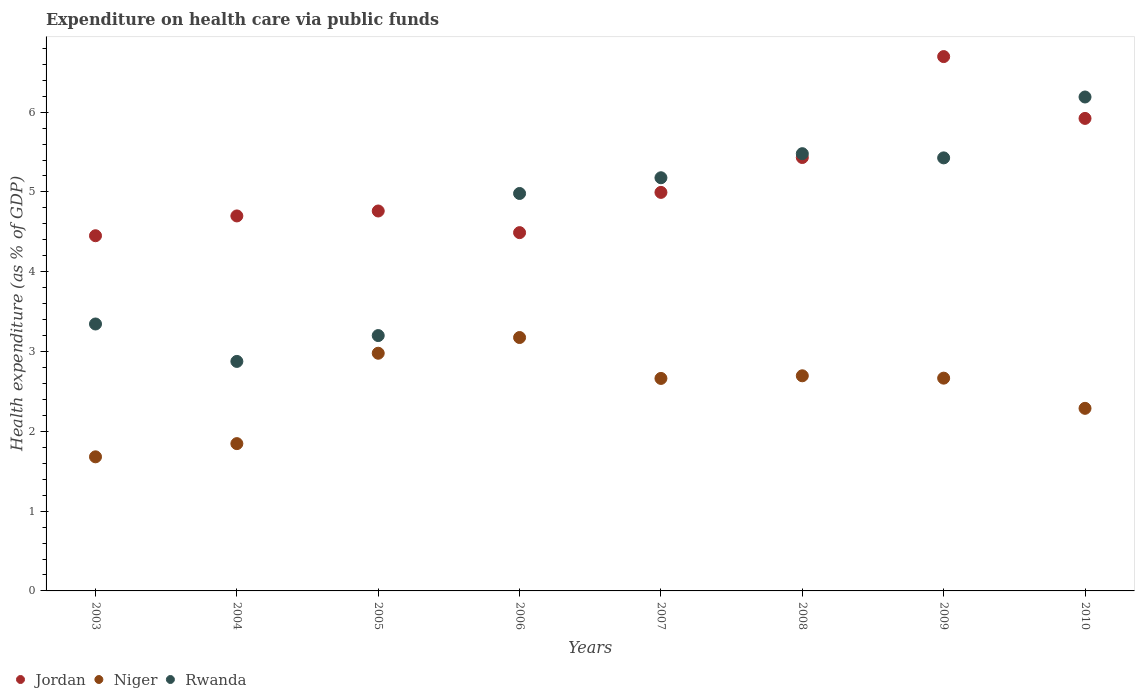Is the number of dotlines equal to the number of legend labels?
Your answer should be very brief. Yes. What is the expenditure made on health care in Niger in 2010?
Ensure brevity in your answer.  2.29. Across all years, what is the maximum expenditure made on health care in Rwanda?
Keep it short and to the point. 6.19. Across all years, what is the minimum expenditure made on health care in Niger?
Keep it short and to the point. 1.68. In which year was the expenditure made on health care in Niger maximum?
Your answer should be very brief. 2006. What is the total expenditure made on health care in Niger in the graph?
Give a very brief answer. 19.99. What is the difference between the expenditure made on health care in Niger in 2008 and that in 2010?
Offer a very short reply. 0.41. What is the difference between the expenditure made on health care in Niger in 2004 and the expenditure made on health care in Jordan in 2007?
Keep it short and to the point. -3.15. What is the average expenditure made on health care in Niger per year?
Give a very brief answer. 2.5. In the year 2006, what is the difference between the expenditure made on health care in Niger and expenditure made on health care in Jordan?
Provide a succinct answer. -1.31. What is the ratio of the expenditure made on health care in Jordan in 2005 to that in 2008?
Your answer should be very brief. 0.88. What is the difference between the highest and the second highest expenditure made on health care in Jordan?
Provide a short and direct response. 0.77. What is the difference between the highest and the lowest expenditure made on health care in Jordan?
Your answer should be compact. 2.24. In how many years, is the expenditure made on health care in Jordan greater than the average expenditure made on health care in Jordan taken over all years?
Your answer should be compact. 3. Is the sum of the expenditure made on health care in Jordan in 2005 and 2008 greater than the maximum expenditure made on health care in Rwanda across all years?
Offer a terse response. Yes. Does the expenditure made on health care in Rwanda monotonically increase over the years?
Your answer should be compact. No. How many dotlines are there?
Your response must be concise. 3. What is the difference between two consecutive major ticks on the Y-axis?
Offer a terse response. 1. Does the graph contain any zero values?
Make the answer very short. No. What is the title of the graph?
Your answer should be compact. Expenditure on health care via public funds. What is the label or title of the Y-axis?
Your answer should be very brief. Health expenditure (as % of GDP). What is the Health expenditure (as % of GDP) of Jordan in 2003?
Your response must be concise. 4.45. What is the Health expenditure (as % of GDP) of Niger in 2003?
Ensure brevity in your answer.  1.68. What is the Health expenditure (as % of GDP) of Rwanda in 2003?
Provide a short and direct response. 3.35. What is the Health expenditure (as % of GDP) in Jordan in 2004?
Your response must be concise. 4.7. What is the Health expenditure (as % of GDP) of Niger in 2004?
Make the answer very short. 1.85. What is the Health expenditure (as % of GDP) in Rwanda in 2004?
Your answer should be very brief. 2.88. What is the Health expenditure (as % of GDP) in Jordan in 2005?
Your answer should be very brief. 4.76. What is the Health expenditure (as % of GDP) of Niger in 2005?
Provide a short and direct response. 2.98. What is the Health expenditure (as % of GDP) of Rwanda in 2005?
Give a very brief answer. 3.2. What is the Health expenditure (as % of GDP) in Jordan in 2006?
Your response must be concise. 4.49. What is the Health expenditure (as % of GDP) in Niger in 2006?
Ensure brevity in your answer.  3.18. What is the Health expenditure (as % of GDP) in Rwanda in 2006?
Your answer should be compact. 4.98. What is the Health expenditure (as % of GDP) in Jordan in 2007?
Give a very brief answer. 4.99. What is the Health expenditure (as % of GDP) of Niger in 2007?
Your response must be concise. 2.66. What is the Health expenditure (as % of GDP) of Rwanda in 2007?
Give a very brief answer. 5.18. What is the Health expenditure (as % of GDP) in Jordan in 2008?
Your answer should be very brief. 5.43. What is the Health expenditure (as % of GDP) in Niger in 2008?
Provide a short and direct response. 2.7. What is the Health expenditure (as % of GDP) in Rwanda in 2008?
Provide a succinct answer. 5.48. What is the Health expenditure (as % of GDP) in Jordan in 2009?
Provide a short and direct response. 6.7. What is the Health expenditure (as % of GDP) in Niger in 2009?
Provide a succinct answer. 2.67. What is the Health expenditure (as % of GDP) in Rwanda in 2009?
Your answer should be very brief. 5.43. What is the Health expenditure (as % of GDP) of Jordan in 2010?
Provide a succinct answer. 5.92. What is the Health expenditure (as % of GDP) in Niger in 2010?
Your response must be concise. 2.29. What is the Health expenditure (as % of GDP) of Rwanda in 2010?
Your answer should be very brief. 6.19. Across all years, what is the maximum Health expenditure (as % of GDP) in Jordan?
Give a very brief answer. 6.7. Across all years, what is the maximum Health expenditure (as % of GDP) of Niger?
Your answer should be very brief. 3.18. Across all years, what is the maximum Health expenditure (as % of GDP) in Rwanda?
Provide a succinct answer. 6.19. Across all years, what is the minimum Health expenditure (as % of GDP) of Jordan?
Your response must be concise. 4.45. Across all years, what is the minimum Health expenditure (as % of GDP) of Niger?
Give a very brief answer. 1.68. Across all years, what is the minimum Health expenditure (as % of GDP) of Rwanda?
Provide a short and direct response. 2.88. What is the total Health expenditure (as % of GDP) of Jordan in the graph?
Your answer should be compact. 41.44. What is the total Health expenditure (as % of GDP) in Niger in the graph?
Provide a short and direct response. 19.99. What is the total Health expenditure (as % of GDP) in Rwanda in the graph?
Keep it short and to the point. 36.67. What is the difference between the Health expenditure (as % of GDP) in Jordan in 2003 and that in 2004?
Provide a short and direct response. -0.25. What is the difference between the Health expenditure (as % of GDP) of Niger in 2003 and that in 2004?
Provide a succinct answer. -0.17. What is the difference between the Health expenditure (as % of GDP) of Rwanda in 2003 and that in 2004?
Make the answer very short. 0.47. What is the difference between the Health expenditure (as % of GDP) of Jordan in 2003 and that in 2005?
Your response must be concise. -0.31. What is the difference between the Health expenditure (as % of GDP) in Niger in 2003 and that in 2005?
Your answer should be very brief. -1.3. What is the difference between the Health expenditure (as % of GDP) in Rwanda in 2003 and that in 2005?
Offer a very short reply. 0.15. What is the difference between the Health expenditure (as % of GDP) of Jordan in 2003 and that in 2006?
Your answer should be very brief. -0.04. What is the difference between the Health expenditure (as % of GDP) of Niger in 2003 and that in 2006?
Your answer should be compact. -1.5. What is the difference between the Health expenditure (as % of GDP) of Rwanda in 2003 and that in 2006?
Your answer should be very brief. -1.64. What is the difference between the Health expenditure (as % of GDP) of Jordan in 2003 and that in 2007?
Offer a very short reply. -0.54. What is the difference between the Health expenditure (as % of GDP) of Niger in 2003 and that in 2007?
Keep it short and to the point. -0.98. What is the difference between the Health expenditure (as % of GDP) in Rwanda in 2003 and that in 2007?
Your answer should be compact. -1.83. What is the difference between the Health expenditure (as % of GDP) of Jordan in 2003 and that in 2008?
Provide a succinct answer. -0.98. What is the difference between the Health expenditure (as % of GDP) of Niger in 2003 and that in 2008?
Make the answer very short. -1.02. What is the difference between the Health expenditure (as % of GDP) in Rwanda in 2003 and that in 2008?
Your answer should be compact. -2.13. What is the difference between the Health expenditure (as % of GDP) in Jordan in 2003 and that in 2009?
Provide a short and direct response. -2.25. What is the difference between the Health expenditure (as % of GDP) of Niger in 2003 and that in 2009?
Your response must be concise. -0.99. What is the difference between the Health expenditure (as % of GDP) in Rwanda in 2003 and that in 2009?
Provide a succinct answer. -2.08. What is the difference between the Health expenditure (as % of GDP) of Jordan in 2003 and that in 2010?
Your answer should be compact. -1.47. What is the difference between the Health expenditure (as % of GDP) in Niger in 2003 and that in 2010?
Ensure brevity in your answer.  -0.61. What is the difference between the Health expenditure (as % of GDP) of Rwanda in 2003 and that in 2010?
Your answer should be compact. -2.84. What is the difference between the Health expenditure (as % of GDP) in Jordan in 2004 and that in 2005?
Give a very brief answer. -0.06. What is the difference between the Health expenditure (as % of GDP) in Niger in 2004 and that in 2005?
Provide a succinct answer. -1.13. What is the difference between the Health expenditure (as % of GDP) in Rwanda in 2004 and that in 2005?
Your answer should be compact. -0.32. What is the difference between the Health expenditure (as % of GDP) in Jordan in 2004 and that in 2006?
Provide a short and direct response. 0.21. What is the difference between the Health expenditure (as % of GDP) of Niger in 2004 and that in 2006?
Provide a short and direct response. -1.33. What is the difference between the Health expenditure (as % of GDP) of Rwanda in 2004 and that in 2006?
Provide a succinct answer. -2.1. What is the difference between the Health expenditure (as % of GDP) in Jordan in 2004 and that in 2007?
Make the answer very short. -0.29. What is the difference between the Health expenditure (as % of GDP) in Niger in 2004 and that in 2007?
Provide a short and direct response. -0.82. What is the difference between the Health expenditure (as % of GDP) in Rwanda in 2004 and that in 2007?
Your answer should be compact. -2.3. What is the difference between the Health expenditure (as % of GDP) of Jordan in 2004 and that in 2008?
Ensure brevity in your answer.  -0.73. What is the difference between the Health expenditure (as % of GDP) in Niger in 2004 and that in 2008?
Keep it short and to the point. -0.85. What is the difference between the Health expenditure (as % of GDP) of Rwanda in 2004 and that in 2008?
Provide a short and direct response. -2.6. What is the difference between the Health expenditure (as % of GDP) of Jordan in 2004 and that in 2009?
Make the answer very short. -2. What is the difference between the Health expenditure (as % of GDP) of Niger in 2004 and that in 2009?
Your answer should be compact. -0.82. What is the difference between the Health expenditure (as % of GDP) of Rwanda in 2004 and that in 2009?
Keep it short and to the point. -2.55. What is the difference between the Health expenditure (as % of GDP) of Jordan in 2004 and that in 2010?
Keep it short and to the point. -1.22. What is the difference between the Health expenditure (as % of GDP) in Niger in 2004 and that in 2010?
Keep it short and to the point. -0.44. What is the difference between the Health expenditure (as % of GDP) in Rwanda in 2004 and that in 2010?
Provide a succinct answer. -3.31. What is the difference between the Health expenditure (as % of GDP) in Jordan in 2005 and that in 2006?
Provide a short and direct response. 0.27. What is the difference between the Health expenditure (as % of GDP) in Niger in 2005 and that in 2006?
Make the answer very short. -0.2. What is the difference between the Health expenditure (as % of GDP) in Rwanda in 2005 and that in 2006?
Your answer should be very brief. -1.78. What is the difference between the Health expenditure (as % of GDP) of Jordan in 2005 and that in 2007?
Provide a succinct answer. -0.23. What is the difference between the Health expenditure (as % of GDP) in Niger in 2005 and that in 2007?
Provide a succinct answer. 0.32. What is the difference between the Health expenditure (as % of GDP) in Rwanda in 2005 and that in 2007?
Keep it short and to the point. -1.98. What is the difference between the Health expenditure (as % of GDP) in Jordan in 2005 and that in 2008?
Your response must be concise. -0.67. What is the difference between the Health expenditure (as % of GDP) of Niger in 2005 and that in 2008?
Offer a terse response. 0.28. What is the difference between the Health expenditure (as % of GDP) in Rwanda in 2005 and that in 2008?
Offer a very short reply. -2.28. What is the difference between the Health expenditure (as % of GDP) in Jordan in 2005 and that in 2009?
Make the answer very short. -1.93. What is the difference between the Health expenditure (as % of GDP) in Niger in 2005 and that in 2009?
Keep it short and to the point. 0.31. What is the difference between the Health expenditure (as % of GDP) in Rwanda in 2005 and that in 2009?
Your response must be concise. -2.23. What is the difference between the Health expenditure (as % of GDP) of Jordan in 2005 and that in 2010?
Your answer should be very brief. -1.16. What is the difference between the Health expenditure (as % of GDP) in Niger in 2005 and that in 2010?
Offer a terse response. 0.69. What is the difference between the Health expenditure (as % of GDP) in Rwanda in 2005 and that in 2010?
Give a very brief answer. -2.99. What is the difference between the Health expenditure (as % of GDP) of Jordan in 2006 and that in 2007?
Your answer should be compact. -0.5. What is the difference between the Health expenditure (as % of GDP) in Niger in 2006 and that in 2007?
Offer a very short reply. 0.51. What is the difference between the Health expenditure (as % of GDP) of Rwanda in 2006 and that in 2007?
Provide a succinct answer. -0.2. What is the difference between the Health expenditure (as % of GDP) in Jordan in 2006 and that in 2008?
Your response must be concise. -0.94. What is the difference between the Health expenditure (as % of GDP) of Niger in 2006 and that in 2008?
Keep it short and to the point. 0.48. What is the difference between the Health expenditure (as % of GDP) of Rwanda in 2006 and that in 2008?
Your answer should be compact. -0.5. What is the difference between the Health expenditure (as % of GDP) in Jordan in 2006 and that in 2009?
Keep it short and to the point. -2.21. What is the difference between the Health expenditure (as % of GDP) in Niger in 2006 and that in 2009?
Ensure brevity in your answer.  0.51. What is the difference between the Health expenditure (as % of GDP) in Rwanda in 2006 and that in 2009?
Make the answer very short. -0.45. What is the difference between the Health expenditure (as % of GDP) of Jordan in 2006 and that in 2010?
Your answer should be very brief. -1.43. What is the difference between the Health expenditure (as % of GDP) in Niger in 2006 and that in 2010?
Keep it short and to the point. 0.89. What is the difference between the Health expenditure (as % of GDP) in Rwanda in 2006 and that in 2010?
Keep it short and to the point. -1.21. What is the difference between the Health expenditure (as % of GDP) in Jordan in 2007 and that in 2008?
Provide a short and direct response. -0.44. What is the difference between the Health expenditure (as % of GDP) in Niger in 2007 and that in 2008?
Keep it short and to the point. -0.03. What is the difference between the Health expenditure (as % of GDP) in Rwanda in 2007 and that in 2008?
Keep it short and to the point. -0.3. What is the difference between the Health expenditure (as % of GDP) of Jordan in 2007 and that in 2009?
Offer a terse response. -1.7. What is the difference between the Health expenditure (as % of GDP) of Niger in 2007 and that in 2009?
Your response must be concise. -0. What is the difference between the Health expenditure (as % of GDP) of Rwanda in 2007 and that in 2009?
Ensure brevity in your answer.  -0.25. What is the difference between the Health expenditure (as % of GDP) in Jordan in 2007 and that in 2010?
Keep it short and to the point. -0.93. What is the difference between the Health expenditure (as % of GDP) of Niger in 2007 and that in 2010?
Offer a terse response. 0.37. What is the difference between the Health expenditure (as % of GDP) in Rwanda in 2007 and that in 2010?
Your answer should be compact. -1.01. What is the difference between the Health expenditure (as % of GDP) of Jordan in 2008 and that in 2009?
Give a very brief answer. -1.26. What is the difference between the Health expenditure (as % of GDP) in Niger in 2008 and that in 2009?
Provide a succinct answer. 0.03. What is the difference between the Health expenditure (as % of GDP) of Rwanda in 2008 and that in 2009?
Provide a succinct answer. 0.05. What is the difference between the Health expenditure (as % of GDP) of Jordan in 2008 and that in 2010?
Offer a terse response. -0.49. What is the difference between the Health expenditure (as % of GDP) of Niger in 2008 and that in 2010?
Ensure brevity in your answer.  0.41. What is the difference between the Health expenditure (as % of GDP) of Rwanda in 2008 and that in 2010?
Keep it short and to the point. -0.71. What is the difference between the Health expenditure (as % of GDP) in Jordan in 2009 and that in 2010?
Make the answer very short. 0.77. What is the difference between the Health expenditure (as % of GDP) in Niger in 2009 and that in 2010?
Offer a terse response. 0.38. What is the difference between the Health expenditure (as % of GDP) in Rwanda in 2009 and that in 2010?
Offer a terse response. -0.76. What is the difference between the Health expenditure (as % of GDP) of Jordan in 2003 and the Health expenditure (as % of GDP) of Niger in 2004?
Your answer should be very brief. 2.61. What is the difference between the Health expenditure (as % of GDP) of Jordan in 2003 and the Health expenditure (as % of GDP) of Rwanda in 2004?
Offer a terse response. 1.58. What is the difference between the Health expenditure (as % of GDP) of Niger in 2003 and the Health expenditure (as % of GDP) of Rwanda in 2004?
Offer a very short reply. -1.2. What is the difference between the Health expenditure (as % of GDP) in Jordan in 2003 and the Health expenditure (as % of GDP) in Niger in 2005?
Give a very brief answer. 1.47. What is the difference between the Health expenditure (as % of GDP) of Jordan in 2003 and the Health expenditure (as % of GDP) of Rwanda in 2005?
Your answer should be very brief. 1.25. What is the difference between the Health expenditure (as % of GDP) of Niger in 2003 and the Health expenditure (as % of GDP) of Rwanda in 2005?
Your response must be concise. -1.52. What is the difference between the Health expenditure (as % of GDP) in Jordan in 2003 and the Health expenditure (as % of GDP) in Niger in 2006?
Keep it short and to the point. 1.28. What is the difference between the Health expenditure (as % of GDP) of Jordan in 2003 and the Health expenditure (as % of GDP) of Rwanda in 2006?
Make the answer very short. -0.53. What is the difference between the Health expenditure (as % of GDP) of Niger in 2003 and the Health expenditure (as % of GDP) of Rwanda in 2006?
Ensure brevity in your answer.  -3.3. What is the difference between the Health expenditure (as % of GDP) in Jordan in 2003 and the Health expenditure (as % of GDP) in Niger in 2007?
Your response must be concise. 1.79. What is the difference between the Health expenditure (as % of GDP) of Jordan in 2003 and the Health expenditure (as % of GDP) of Rwanda in 2007?
Your response must be concise. -0.73. What is the difference between the Health expenditure (as % of GDP) in Niger in 2003 and the Health expenditure (as % of GDP) in Rwanda in 2007?
Keep it short and to the point. -3.5. What is the difference between the Health expenditure (as % of GDP) of Jordan in 2003 and the Health expenditure (as % of GDP) of Niger in 2008?
Offer a terse response. 1.76. What is the difference between the Health expenditure (as % of GDP) of Jordan in 2003 and the Health expenditure (as % of GDP) of Rwanda in 2008?
Offer a very short reply. -1.03. What is the difference between the Health expenditure (as % of GDP) in Niger in 2003 and the Health expenditure (as % of GDP) in Rwanda in 2008?
Provide a short and direct response. -3.8. What is the difference between the Health expenditure (as % of GDP) of Jordan in 2003 and the Health expenditure (as % of GDP) of Niger in 2009?
Your answer should be very brief. 1.78. What is the difference between the Health expenditure (as % of GDP) of Jordan in 2003 and the Health expenditure (as % of GDP) of Rwanda in 2009?
Make the answer very short. -0.98. What is the difference between the Health expenditure (as % of GDP) in Niger in 2003 and the Health expenditure (as % of GDP) in Rwanda in 2009?
Give a very brief answer. -3.75. What is the difference between the Health expenditure (as % of GDP) of Jordan in 2003 and the Health expenditure (as % of GDP) of Niger in 2010?
Your answer should be compact. 2.16. What is the difference between the Health expenditure (as % of GDP) in Jordan in 2003 and the Health expenditure (as % of GDP) in Rwanda in 2010?
Your answer should be compact. -1.74. What is the difference between the Health expenditure (as % of GDP) in Niger in 2003 and the Health expenditure (as % of GDP) in Rwanda in 2010?
Make the answer very short. -4.51. What is the difference between the Health expenditure (as % of GDP) in Jordan in 2004 and the Health expenditure (as % of GDP) in Niger in 2005?
Offer a terse response. 1.72. What is the difference between the Health expenditure (as % of GDP) of Jordan in 2004 and the Health expenditure (as % of GDP) of Rwanda in 2005?
Provide a short and direct response. 1.5. What is the difference between the Health expenditure (as % of GDP) in Niger in 2004 and the Health expenditure (as % of GDP) in Rwanda in 2005?
Provide a succinct answer. -1.35. What is the difference between the Health expenditure (as % of GDP) in Jordan in 2004 and the Health expenditure (as % of GDP) in Niger in 2006?
Your answer should be very brief. 1.52. What is the difference between the Health expenditure (as % of GDP) in Jordan in 2004 and the Health expenditure (as % of GDP) in Rwanda in 2006?
Make the answer very short. -0.28. What is the difference between the Health expenditure (as % of GDP) of Niger in 2004 and the Health expenditure (as % of GDP) of Rwanda in 2006?
Offer a very short reply. -3.13. What is the difference between the Health expenditure (as % of GDP) in Jordan in 2004 and the Health expenditure (as % of GDP) in Niger in 2007?
Offer a terse response. 2.04. What is the difference between the Health expenditure (as % of GDP) of Jordan in 2004 and the Health expenditure (as % of GDP) of Rwanda in 2007?
Your answer should be compact. -0.48. What is the difference between the Health expenditure (as % of GDP) in Niger in 2004 and the Health expenditure (as % of GDP) in Rwanda in 2007?
Your answer should be compact. -3.33. What is the difference between the Health expenditure (as % of GDP) in Jordan in 2004 and the Health expenditure (as % of GDP) in Niger in 2008?
Your response must be concise. 2. What is the difference between the Health expenditure (as % of GDP) of Jordan in 2004 and the Health expenditure (as % of GDP) of Rwanda in 2008?
Your answer should be compact. -0.78. What is the difference between the Health expenditure (as % of GDP) of Niger in 2004 and the Health expenditure (as % of GDP) of Rwanda in 2008?
Provide a succinct answer. -3.63. What is the difference between the Health expenditure (as % of GDP) of Jordan in 2004 and the Health expenditure (as % of GDP) of Niger in 2009?
Your answer should be compact. 2.03. What is the difference between the Health expenditure (as % of GDP) of Jordan in 2004 and the Health expenditure (as % of GDP) of Rwanda in 2009?
Give a very brief answer. -0.73. What is the difference between the Health expenditure (as % of GDP) in Niger in 2004 and the Health expenditure (as % of GDP) in Rwanda in 2009?
Ensure brevity in your answer.  -3.58. What is the difference between the Health expenditure (as % of GDP) in Jordan in 2004 and the Health expenditure (as % of GDP) in Niger in 2010?
Offer a terse response. 2.41. What is the difference between the Health expenditure (as % of GDP) of Jordan in 2004 and the Health expenditure (as % of GDP) of Rwanda in 2010?
Offer a terse response. -1.49. What is the difference between the Health expenditure (as % of GDP) of Niger in 2004 and the Health expenditure (as % of GDP) of Rwanda in 2010?
Provide a succinct answer. -4.34. What is the difference between the Health expenditure (as % of GDP) in Jordan in 2005 and the Health expenditure (as % of GDP) in Niger in 2006?
Provide a short and direct response. 1.59. What is the difference between the Health expenditure (as % of GDP) of Jordan in 2005 and the Health expenditure (as % of GDP) of Rwanda in 2006?
Keep it short and to the point. -0.22. What is the difference between the Health expenditure (as % of GDP) in Niger in 2005 and the Health expenditure (as % of GDP) in Rwanda in 2006?
Your answer should be very brief. -2. What is the difference between the Health expenditure (as % of GDP) in Jordan in 2005 and the Health expenditure (as % of GDP) in Niger in 2007?
Give a very brief answer. 2.1. What is the difference between the Health expenditure (as % of GDP) of Jordan in 2005 and the Health expenditure (as % of GDP) of Rwanda in 2007?
Keep it short and to the point. -0.42. What is the difference between the Health expenditure (as % of GDP) in Niger in 2005 and the Health expenditure (as % of GDP) in Rwanda in 2007?
Provide a succinct answer. -2.2. What is the difference between the Health expenditure (as % of GDP) of Jordan in 2005 and the Health expenditure (as % of GDP) of Niger in 2008?
Keep it short and to the point. 2.07. What is the difference between the Health expenditure (as % of GDP) of Jordan in 2005 and the Health expenditure (as % of GDP) of Rwanda in 2008?
Make the answer very short. -0.72. What is the difference between the Health expenditure (as % of GDP) of Niger in 2005 and the Health expenditure (as % of GDP) of Rwanda in 2008?
Your answer should be very brief. -2.5. What is the difference between the Health expenditure (as % of GDP) of Jordan in 2005 and the Health expenditure (as % of GDP) of Niger in 2009?
Make the answer very short. 2.09. What is the difference between the Health expenditure (as % of GDP) of Jordan in 2005 and the Health expenditure (as % of GDP) of Rwanda in 2009?
Make the answer very short. -0.67. What is the difference between the Health expenditure (as % of GDP) in Niger in 2005 and the Health expenditure (as % of GDP) in Rwanda in 2009?
Provide a succinct answer. -2.45. What is the difference between the Health expenditure (as % of GDP) of Jordan in 2005 and the Health expenditure (as % of GDP) of Niger in 2010?
Offer a terse response. 2.47. What is the difference between the Health expenditure (as % of GDP) in Jordan in 2005 and the Health expenditure (as % of GDP) in Rwanda in 2010?
Offer a very short reply. -1.43. What is the difference between the Health expenditure (as % of GDP) in Niger in 2005 and the Health expenditure (as % of GDP) in Rwanda in 2010?
Give a very brief answer. -3.21. What is the difference between the Health expenditure (as % of GDP) in Jordan in 2006 and the Health expenditure (as % of GDP) in Niger in 2007?
Offer a terse response. 1.83. What is the difference between the Health expenditure (as % of GDP) of Jordan in 2006 and the Health expenditure (as % of GDP) of Rwanda in 2007?
Your response must be concise. -0.69. What is the difference between the Health expenditure (as % of GDP) of Niger in 2006 and the Health expenditure (as % of GDP) of Rwanda in 2007?
Give a very brief answer. -2. What is the difference between the Health expenditure (as % of GDP) in Jordan in 2006 and the Health expenditure (as % of GDP) in Niger in 2008?
Provide a short and direct response. 1.79. What is the difference between the Health expenditure (as % of GDP) in Jordan in 2006 and the Health expenditure (as % of GDP) in Rwanda in 2008?
Your answer should be very brief. -0.99. What is the difference between the Health expenditure (as % of GDP) in Niger in 2006 and the Health expenditure (as % of GDP) in Rwanda in 2008?
Offer a very short reply. -2.3. What is the difference between the Health expenditure (as % of GDP) in Jordan in 2006 and the Health expenditure (as % of GDP) in Niger in 2009?
Your response must be concise. 1.82. What is the difference between the Health expenditure (as % of GDP) of Jordan in 2006 and the Health expenditure (as % of GDP) of Rwanda in 2009?
Offer a terse response. -0.94. What is the difference between the Health expenditure (as % of GDP) in Niger in 2006 and the Health expenditure (as % of GDP) in Rwanda in 2009?
Give a very brief answer. -2.25. What is the difference between the Health expenditure (as % of GDP) in Jordan in 2006 and the Health expenditure (as % of GDP) in Niger in 2010?
Ensure brevity in your answer.  2.2. What is the difference between the Health expenditure (as % of GDP) of Jordan in 2006 and the Health expenditure (as % of GDP) of Rwanda in 2010?
Ensure brevity in your answer.  -1.7. What is the difference between the Health expenditure (as % of GDP) of Niger in 2006 and the Health expenditure (as % of GDP) of Rwanda in 2010?
Your answer should be compact. -3.01. What is the difference between the Health expenditure (as % of GDP) in Jordan in 2007 and the Health expenditure (as % of GDP) in Niger in 2008?
Your response must be concise. 2.3. What is the difference between the Health expenditure (as % of GDP) in Jordan in 2007 and the Health expenditure (as % of GDP) in Rwanda in 2008?
Provide a short and direct response. -0.48. What is the difference between the Health expenditure (as % of GDP) of Niger in 2007 and the Health expenditure (as % of GDP) of Rwanda in 2008?
Ensure brevity in your answer.  -2.82. What is the difference between the Health expenditure (as % of GDP) in Jordan in 2007 and the Health expenditure (as % of GDP) in Niger in 2009?
Keep it short and to the point. 2.33. What is the difference between the Health expenditure (as % of GDP) of Jordan in 2007 and the Health expenditure (as % of GDP) of Rwanda in 2009?
Offer a terse response. -0.43. What is the difference between the Health expenditure (as % of GDP) of Niger in 2007 and the Health expenditure (as % of GDP) of Rwanda in 2009?
Your answer should be very brief. -2.76. What is the difference between the Health expenditure (as % of GDP) in Jordan in 2007 and the Health expenditure (as % of GDP) in Niger in 2010?
Make the answer very short. 2.71. What is the difference between the Health expenditure (as % of GDP) of Jordan in 2007 and the Health expenditure (as % of GDP) of Rwanda in 2010?
Offer a very short reply. -1.2. What is the difference between the Health expenditure (as % of GDP) in Niger in 2007 and the Health expenditure (as % of GDP) in Rwanda in 2010?
Keep it short and to the point. -3.53. What is the difference between the Health expenditure (as % of GDP) in Jordan in 2008 and the Health expenditure (as % of GDP) in Niger in 2009?
Your response must be concise. 2.76. What is the difference between the Health expenditure (as % of GDP) in Jordan in 2008 and the Health expenditure (as % of GDP) in Rwanda in 2009?
Your answer should be compact. 0. What is the difference between the Health expenditure (as % of GDP) of Niger in 2008 and the Health expenditure (as % of GDP) of Rwanda in 2009?
Offer a very short reply. -2.73. What is the difference between the Health expenditure (as % of GDP) in Jordan in 2008 and the Health expenditure (as % of GDP) in Niger in 2010?
Offer a very short reply. 3.14. What is the difference between the Health expenditure (as % of GDP) in Jordan in 2008 and the Health expenditure (as % of GDP) in Rwanda in 2010?
Make the answer very short. -0.76. What is the difference between the Health expenditure (as % of GDP) of Niger in 2008 and the Health expenditure (as % of GDP) of Rwanda in 2010?
Offer a very short reply. -3.49. What is the difference between the Health expenditure (as % of GDP) in Jordan in 2009 and the Health expenditure (as % of GDP) in Niger in 2010?
Offer a very short reply. 4.41. What is the difference between the Health expenditure (as % of GDP) in Jordan in 2009 and the Health expenditure (as % of GDP) in Rwanda in 2010?
Give a very brief answer. 0.51. What is the difference between the Health expenditure (as % of GDP) in Niger in 2009 and the Health expenditure (as % of GDP) in Rwanda in 2010?
Your answer should be very brief. -3.52. What is the average Health expenditure (as % of GDP) in Jordan per year?
Your answer should be compact. 5.18. What is the average Health expenditure (as % of GDP) in Niger per year?
Keep it short and to the point. 2.5. What is the average Health expenditure (as % of GDP) of Rwanda per year?
Ensure brevity in your answer.  4.58. In the year 2003, what is the difference between the Health expenditure (as % of GDP) in Jordan and Health expenditure (as % of GDP) in Niger?
Your answer should be very brief. 2.77. In the year 2003, what is the difference between the Health expenditure (as % of GDP) in Jordan and Health expenditure (as % of GDP) in Rwanda?
Offer a terse response. 1.11. In the year 2003, what is the difference between the Health expenditure (as % of GDP) in Niger and Health expenditure (as % of GDP) in Rwanda?
Your answer should be very brief. -1.66. In the year 2004, what is the difference between the Health expenditure (as % of GDP) in Jordan and Health expenditure (as % of GDP) in Niger?
Your answer should be compact. 2.85. In the year 2004, what is the difference between the Health expenditure (as % of GDP) of Jordan and Health expenditure (as % of GDP) of Rwanda?
Your answer should be compact. 1.82. In the year 2004, what is the difference between the Health expenditure (as % of GDP) in Niger and Health expenditure (as % of GDP) in Rwanda?
Provide a short and direct response. -1.03. In the year 2005, what is the difference between the Health expenditure (as % of GDP) of Jordan and Health expenditure (as % of GDP) of Niger?
Offer a very short reply. 1.78. In the year 2005, what is the difference between the Health expenditure (as % of GDP) of Jordan and Health expenditure (as % of GDP) of Rwanda?
Provide a short and direct response. 1.56. In the year 2005, what is the difference between the Health expenditure (as % of GDP) of Niger and Health expenditure (as % of GDP) of Rwanda?
Make the answer very short. -0.22. In the year 2006, what is the difference between the Health expenditure (as % of GDP) of Jordan and Health expenditure (as % of GDP) of Niger?
Provide a short and direct response. 1.31. In the year 2006, what is the difference between the Health expenditure (as % of GDP) in Jordan and Health expenditure (as % of GDP) in Rwanda?
Your response must be concise. -0.49. In the year 2006, what is the difference between the Health expenditure (as % of GDP) of Niger and Health expenditure (as % of GDP) of Rwanda?
Offer a terse response. -1.81. In the year 2007, what is the difference between the Health expenditure (as % of GDP) of Jordan and Health expenditure (as % of GDP) of Niger?
Ensure brevity in your answer.  2.33. In the year 2007, what is the difference between the Health expenditure (as % of GDP) of Jordan and Health expenditure (as % of GDP) of Rwanda?
Provide a succinct answer. -0.18. In the year 2007, what is the difference between the Health expenditure (as % of GDP) in Niger and Health expenditure (as % of GDP) in Rwanda?
Offer a very short reply. -2.51. In the year 2008, what is the difference between the Health expenditure (as % of GDP) of Jordan and Health expenditure (as % of GDP) of Niger?
Your answer should be very brief. 2.74. In the year 2008, what is the difference between the Health expenditure (as % of GDP) of Jordan and Health expenditure (as % of GDP) of Rwanda?
Provide a short and direct response. -0.05. In the year 2008, what is the difference between the Health expenditure (as % of GDP) of Niger and Health expenditure (as % of GDP) of Rwanda?
Provide a succinct answer. -2.78. In the year 2009, what is the difference between the Health expenditure (as % of GDP) in Jordan and Health expenditure (as % of GDP) in Niger?
Your answer should be very brief. 4.03. In the year 2009, what is the difference between the Health expenditure (as % of GDP) in Jordan and Health expenditure (as % of GDP) in Rwanda?
Make the answer very short. 1.27. In the year 2009, what is the difference between the Health expenditure (as % of GDP) of Niger and Health expenditure (as % of GDP) of Rwanda?
Give a very brief answer. -2.76. In the year 2010, what is the difference between the Health expenditure (as % of GDP) in Jordan and Health expenditure (as % of GDP) in Niger?
Provide a succinct answer. 3.63. In the year 2010, what is the difference between the Health expenditure (as % of GDP) in Jordan and Health expenditure (as % of GDP) in Rwanda?
Your response must be concise. -0.27. In the year 2010, what is the difference between the Health expenditure (as % of GDP) of Niger and Health expenditure (as % of GDP) of Rwanda?
Keep it short and to the point. -3.9. What is the ratio of the Health expenditure (as % of GDP) of Jordan in 2003 to that in 2004?
Offer a terse response. 0.95. What is the ratio of the Health expenditure (as % of GDP) in Niger in 2003 to that in 2004?
Keep it short and to the point. 0.91. What is the ratio of the Health expenditure (as % of GDP) in Rwanda in 2003 to that in 2004?
Give a very brief answer. 1.16. What is the ratio of the Health expenditure (as % of GDP) of Jordan in 2003 to that in 2005?
Provide a short and direct response. 0.93. What is the ratio of the Health expenditure (as % of GDP) of Niger in 2003 to that in 2005?
Offer a very short reply. 0.56. What is the ratio of the Health expenditure (as % of GDP) in Rwanda in 2003 to that in 2005?
Keep it short and to the point. 1.05. What is the ratio of the Health expenditure (as % of GDP) of Jordan in 2003 to that in 2006?
Provide a short and direct response. 0.99. What is the ratio of the Health expenditure (as % of GDP) in Niger in 2003 to that in 2006?
Provide a short and direct response. 0.53. What is the ratio of the Health expenditure (as % of GDP) in Rwanda in 2003 to that in 2006?
Make the answer very short. 0.67. What is the ratio of the Health expenditure (as % of GDP) of Jordan in 2003 to that in 2007?
Give a very brief answer. 0.89. What is the ratio of the Health expenditure (as % of GDP) of Niger in 2003 to that in 2007?
Offer a very short reply. 0.63. What is the ratio of the Health expenditure (as % of GDP) of Rwanda in 2003 to that in 2007?
Your answer should be compact. 0.65. What is the ratio of the Health expenditure (as % of GDP) of Jordan in 2003 to that in 2008?
Make the answer very short. 0.82. What is the ratio of the Health expenditure (as % of GDP) in Niger in 2003 to that in 2008?
Keep it short and to the point. 0.62. What is the ratio of the Health expenditure (as % of GDP) of Rwanda in 2003 to that in 2008?
Offer a very short reply. 0.61. What is the ratio of the Health expenditure (as % of GDP) in Jordan in 2003 to that in 2009?
Offer a terse response. 0.66. What is the ratio of the Health expenditure (as % of GDP) in Niger in 2003 to that in 2009?
Offer a very short reply. 0.63. What is the ratio of the Health expenditure (as % of GDP) in Rwanda in 2003 to that in 2009?
Provide a short and direct response. 0.62. What is the ratio of the Health expenditure (as % of GDP) in Jordan in 2003 to that in 2010?
Provide a succinct answer. 0.75. What is the ratio of the Health expenditure (as % of GDP) in Niger in 2003 to that in 2010?
Ensure brevity in your answer.  0.73. What is the ratio of the Health expenditure (as % of GDP) in Rwanda in 2003 to that in 2010?
Ensure brevity in your answer.  0.54. What is the ratio of the Health expenditure (as % of GDP) of Niger in 2004 to that in 2005?
Keep it short and to the point. 0.62. What is the ratio of the Health expenditure (as % of GDP) in Rwanda in 2004 to that in 2005?
Your response must be concise. 0.9. What is the ratio of the Health expenditure (as % of GDP) in Jordan in 2004 to that in 2006?
Ensure brevity in your answer.  1.05. What is the ratio of the Health expenditure (as % of GDP) of Niger in 2004 to that in 2006?
Ensure brevity in your answer.  0.58. What is the ratio of the Health expenditure (as % of GDP) of Rwanda in 2004 to that in 2006?
Provide a short and direct response. 0.58. What is the ratio of the Health expenditure (as % of GDP) of Jordan in 2004 to that in 2007?
Offer a terse response. 0.94. What is the ratio of the Health expenditure (as % of GDP) in Niger in 2004 to that in 2007?
Your answer should be very brief. 0.69. What is the ratio of the Health expenditure (as % of GDP) in Rwanda in 2004 to that in 2007?
Your answer should be compact. 0.56. What is the ratio of the Health expenditure (as % of GDP) of Jordan in 2004 to that in 2008?
Your answer should be compact. 0.87. What is the ratio of the Health expenditure (as % of GDP) in Niger in 2004 to that in 2008?
Your response must be concise. 0.68. What is the ratio of the Health expenditure (as % of GDP) in Rwanda in 2004 to that in 2008?
Offer a terse response. 0.52. What is the ratio of the Health expenditure (as % of GDP) in Jordan in 2004 to that in 2009?
Keep it short and to the point. 0.7. What is the ratio of the Health expenditure (as % of GDP) of Niger in 2004 to that in 2009?
Provide a succinct answer. 0.69. What is the ratio of the Health expenditure (as % of GDP) in Rwanda in 2004 to that in 2009?
Your response must be concise. 0.53. What is the ratio of the Health expenditure (as % of GDP) of Jordan in 2004 to that in 2010?
Your answer should be very brief. 0.79. What is the ratio of the Health expenditure (as % of GDP) in Niger in 2004 to that in 2010?
Make the answer very short. 0.81. What is the ratio of the Health expenditure (as % of GDP) in Rwanda in 2004 to that in 2010?
Offer a terse response. 0.46. What is the ratio of the Health expenditure (as % of GDP) of Jordan in 2005 to that in 2006?
Keep it short and to the point. 1.06. What is the ratio of the Health expenditure (as % of GDP) in Niger in 2005 to that in 2006?
Keep it short and to the point. 0.94. What is the ratio of the Health expenditure (as % of GDP) of Rwanda in 2005 to that in 2006?
Provide a short and direct response. 0.64. What is the ratio of the Health expenditure (as % of GDP) in Jordan in 2005 to that in 2007?
Make the answer very short. 0.95. What is the ratio of the Health expenditure (as % of GDP) in Niger in 2005 to that in 2007?
Ensure brevity in your answer.  1.12. What is the ratio of the Health expenditure (as % of GDP) of Rwanda in 2005 to that in 2007?
Your answer should be very brief. 0.62. What is the ratio of the Health expenditure (as % of GDP) of Jordan in 2005 to that in 2008?
Your response must be concise. 0.88. What is the ratio of the Health expenditure (as % of GDP) of Niger in 2005 to that in 2008?
Your answer should be very brief. 1.1. What is the ratio of the Health expenditure (as % of GDP) in Rwanda in 2005 to that in 2008?
Your answer should be very brief. 0.58. What is the ratio of the Health expenditure (as % of GDP) of Jordan in 2005 to that in 2009?
Your answer should be compact. 0.71. What is the ratio of the Health expenditure (as % of GDP) in Niger in 2005 to that in 2009?
Offer a terse response. 1.12. What is the ratio of the Health expenditure (as % of GDP) of Rwanda in 2005 to that in 2009?
Offer a very short reply. 0.59. What is the ratio of the Health expenditure (as % of GDP) of Jordan in 2005 to that in 2010?
Your answer should be compact. 0.8. What is the ratio of the Health expenditure (as % of GDP) of Niger in 2005 to that in 2010?
Keep it short and to the point. 1.3. What is the ratio of the Health expenditure (as % of GDP) in Rwanda in 2005 to that in 2010?
Make the answer very short. 0.52. What is the ratio of the Health expenditure (as % of GDP) of Jordan in 2006 to that in 2007?
Your response must be concise. 0.9. What is the ratio of the Health expenditure (as % of GDP) of Niger in 2006 to that in 2007?
Provide a succinct answer. 1.19. What is the ratio of the Health expenditure (as % of GDP) in Rwanda in 2006 to that in 2007?
Provide a short and direct response. 0.96. What is the ratio of the Health expenditure (as % of GDP) in Jordan in 2006 to that in 2008?
Ensure brevity in your answer.  0.83. What is the ratio of the Health expenditure (as % of GDP) of Niger in 2006 to that in 2008?
Your answer should be very brief. 1.18. What is the ratio of the Health expenditure (as % of GDP) of Rwanda in 2006 to that in 2008?
Offer a very short reply. 0.91. What is the ratio of the Health expenditure (as % of GDP) in Jordan in 2006 to that in 2009?
Ensure brevity in your answer.  0.67. What is the ratio of the Health expenditure (as % of GDP) in Niger in 2006 to that in 2009?
Keep it short and to the point. 1.19. What is the ratio of the Health expenditure (as % of GDP) of Rwanda in 2006 to that in 2009?
Your answer should be compact. 0.92. What is the ratio of the Health expenditure (as % of GDP) of Jordan in 2006 to that in 2010?
Your response must be concise. 0.76. What is the ratio of the Health expenditure (as % of GDP) in Niger in 2006 to that in 2010?
Your response must be concise. 1.39. What is the ratio of the Health expenditure (as % of GDP) in Rwanda in 2006 to that in 2010?
Provide a succinct answer. 0.8. What is the ratio of the Health expenditure (as % of GDP) of Jordan in 2007 to that in 2008?
Your answer should be compact. 0.92. What is the ratio of the Health expenditure (as % of GDP) in Niger in 2007 to that in 2008?
Offer a very short reply. 0.99. What is the ratio of the Health expenditure (as % of GDP) of Rwanda in 2007 to that in 2008?
Offer a terse response. 0.94. What is the ratio of the Health expenditure (as % of GDP) of Jordan in 2007 to that in 2009?
Offer a terse response. 0.75. What is the ratio of the Health expenditure (as % of GDP) of Rwanda in 2007 to that in 2009?
Keep it short and to the point. 0.95. What is the ratio of the Health expenditure (as % of GDP) of Jordan in 2007 to that in 2010?
Provide a succinct answer. 0.84. What is the ratio of the Health expenditure (as % of GDP) in Niger in 2007 to that in 2010?
Your response must be concise. 1.16. What is the ratio of the Health expenditure (as % of GDP) of Rwanda in 2007 to that in 2010?
Your answer should be very brief. 0.84. What is the ratio of the Health expenditure (as % of GDP) of Jordan in 2008 to that in 2009?
Give a very brief answer. 0.81. What is the ratio of the Health expenditure (as % of GDP) of Niger in 2008 to that in 2009?
Ensure brevity in your answer.  1.01. What is the ratio of the Health expenditure (as % of GDP) of Rwanda in 2008 to that in 2009?
Give a very brief answer. 1.01. What is the ratio of the Health expenditure (as % of GDP) of Jordan in 2008 to that in 2010?
Provide a short and direct response. 0.92. What is the ratio of the Health expenditure (as % of GDP) in Niger in 2008 to that in 2010?
Your response must be concise. 1.18. What is the ratio of the Health expenditure (as % of GDP) in Rwanda in 2008 to that in 2010?
Ensure brevity in your answer.  0.89. What is the ratio of the Health expenditure (as % of GDP) of Jordan in 2009 to that in 2010?
Your answer should be compact. 1.13. What is the ratio of the Health expenditure (as % of GDP) in Niger in 2009 to that in 2010?
Make the answer very short. 1.17. What is the ratio of the Health expenditure (as % of GDP) in Rwanda in 2009 to that in 2010?
Make the answer very short. 0.88. What is the difference between the highest and the second highest Health expenditure (as % of GDP) of Jordan?
Make the answer very short. 0.77. What is the difference between the highest and the second highest Health expenditure (as % of GDP) in Niger?
Your response must be concise. 0.2. What is the difference between the highest and the second highest Health expenditure (as % of GDP) in Rwanda?
Your answer should be very brief. 0.71. What is the difference between the highest and the lowest Health expenditure (as % of GDP) of Jordan?
Your answer should be compact. 2.25. What is the difference between the highest and the lowest Health expenditure (as % of GDP) of Niger?
Make the answer very short. 1.5. What is the difference between the highest and the lowest Health expenditure (as % of GDP) of Rwanda?
Offer a terse response. 3.31. 